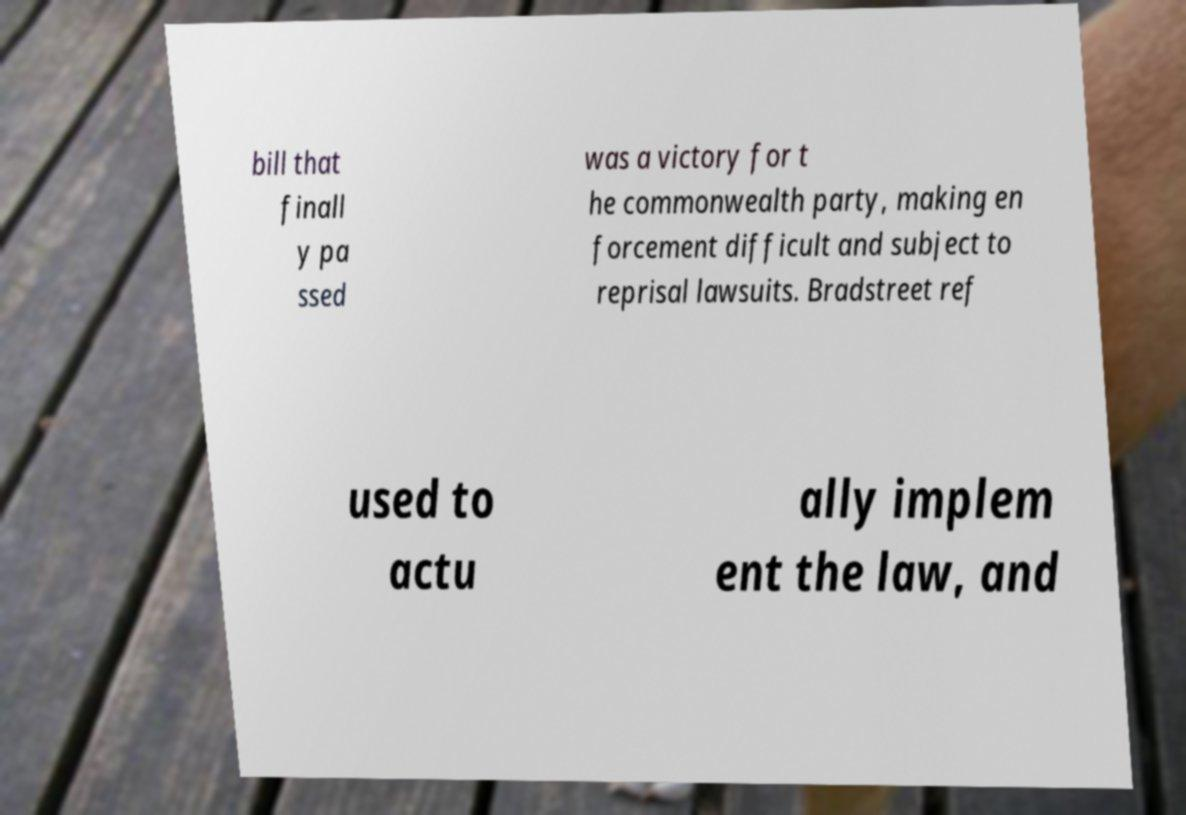What messages or text are displayed in this image? I need them in a readable, typed format. bill that finall y pa ssed was a victory for t he commonwealth party, making en forcement difficult and subject to reprisal lawsuits. Bradstreet ref used to actu ally implem ent the law, and 